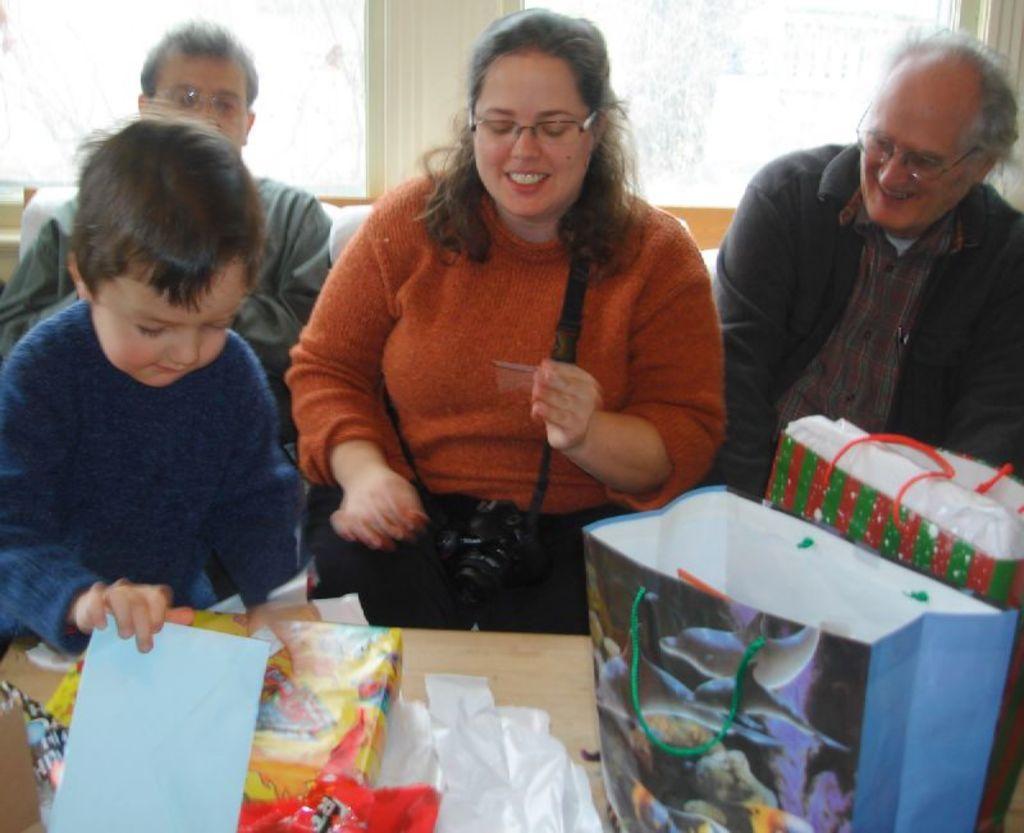Please provide a concise description of this image. In this image I can see 4 people sitting in a room. There are carry bags and gifts in front of them. There is a window at the back. 